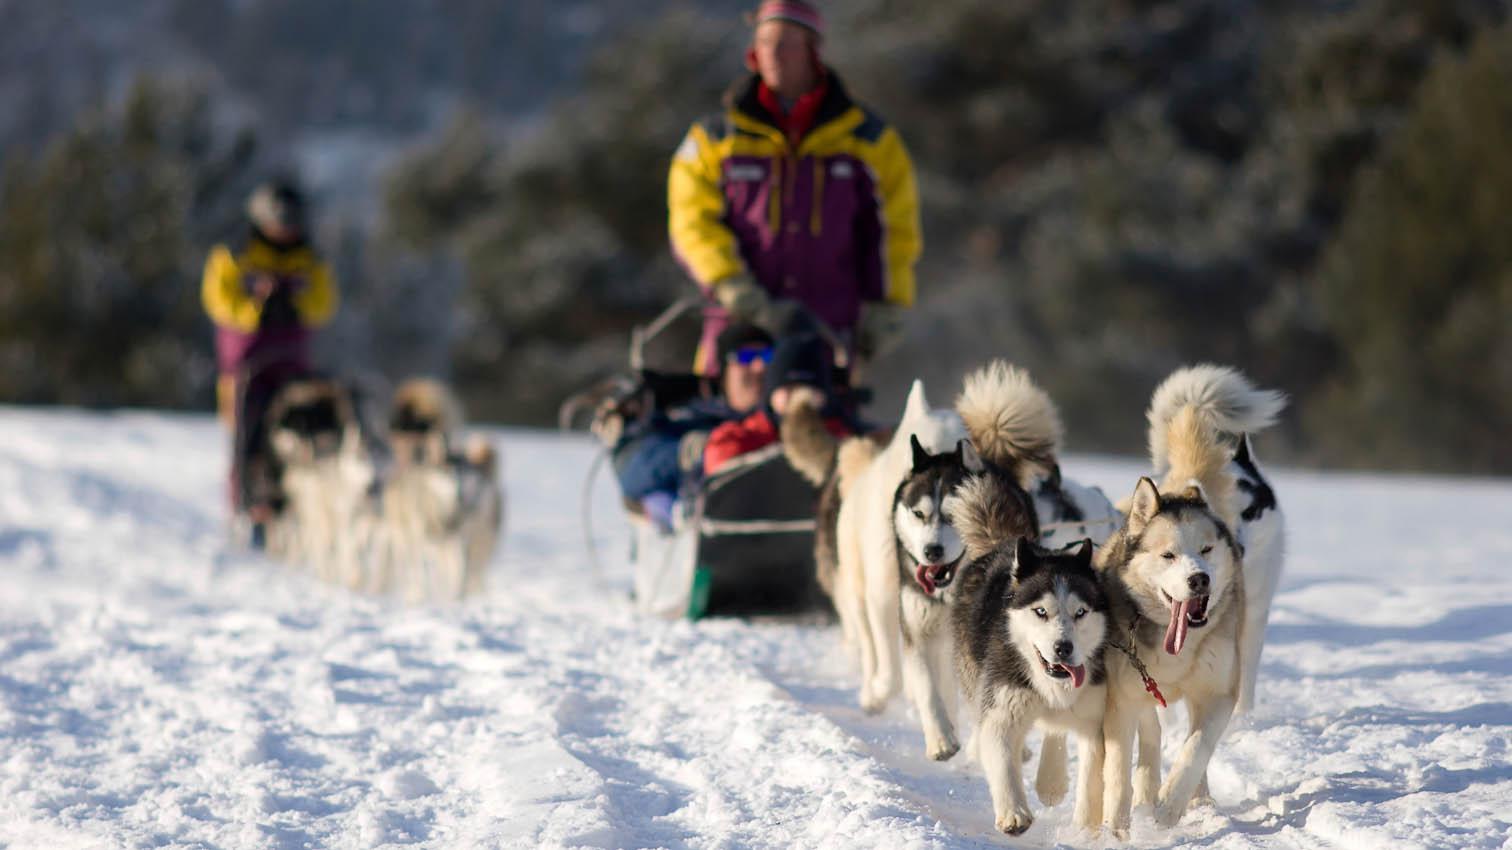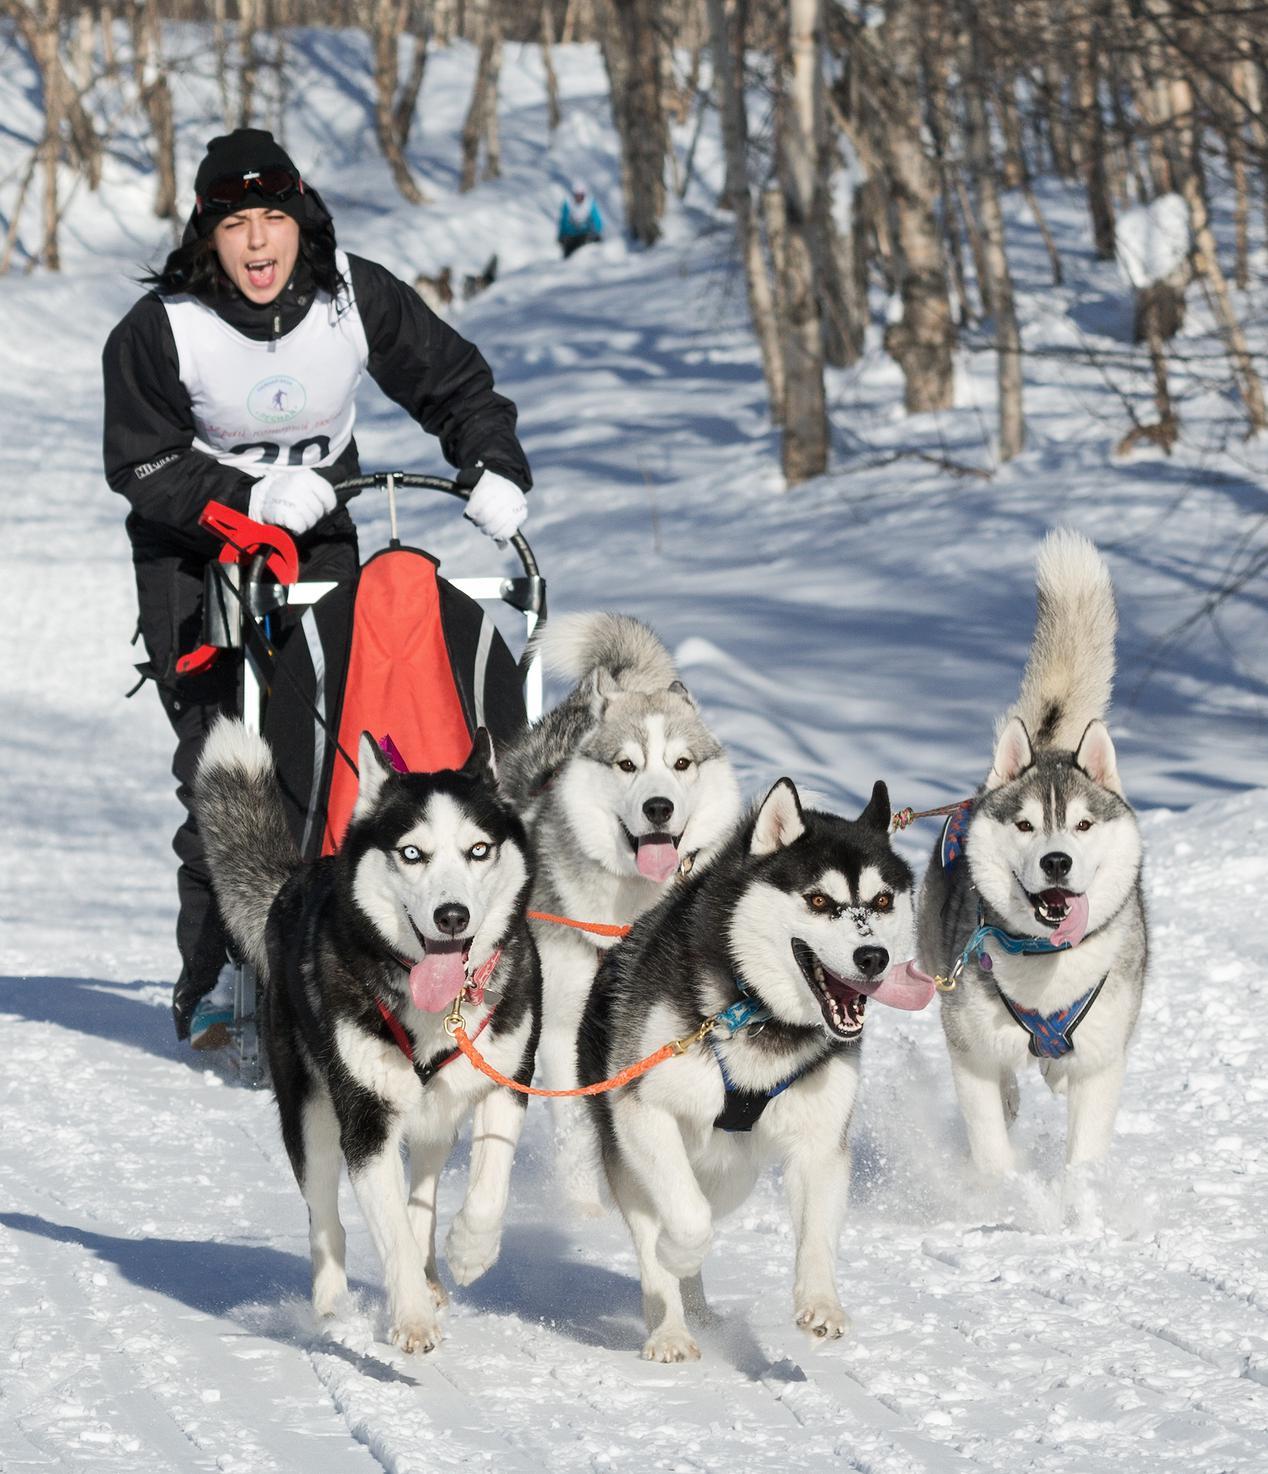The first image is the image on the left, the second image is the image on the right. For the images displayed, is the sentence "Only one person can be seen with each of two teams of dogs." factually correct? Answer yes or no. No. The first image is the image on the left, the second image is the image on the right. For the images shown, is this caption "One image features a sled driver wearing glasses and a white race vest." true? Answer yes or no. No. 